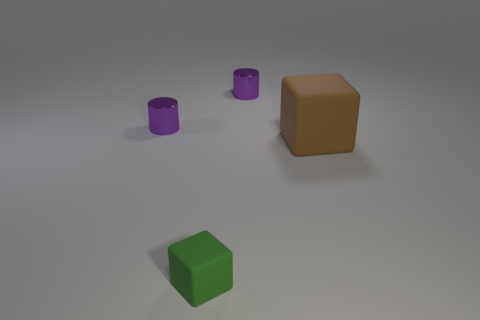Add 4 big things. How many objects exist? 8 Subtract 0 red spheres. How many objects are left? 4 Subtract all tiny purple shiny objects. Subtract all large matte cubes. How many objects are left? 1 Add 3 small things. How many small things are left? 6 Add 4 big brown matte things. How many big brown matte things exist? 5 